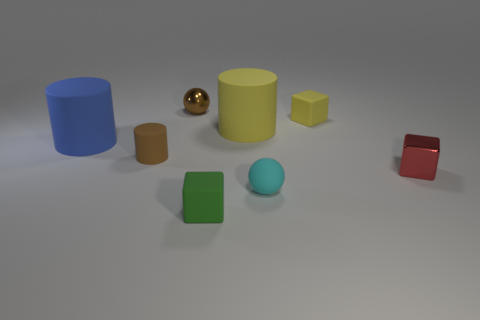Subtract all tiny cylinders. How many cylinders are left? 2 Subtract 1 cubes. How many cubes are left? 2 Add 1 large yellow matte blocks. How many objects exist? 9 Subtract all spheres. How many objects are left? 6 Subtract 1 red blocks. How many objects are left? 7 Subtract all tiny brown balls. Subtract all big rubber objects. How many objects are left? 5 Add 1 metallic objects. How many metallic objects are left? 3 Add 8 yellow cubes. How many yellow cubes exist? 9 